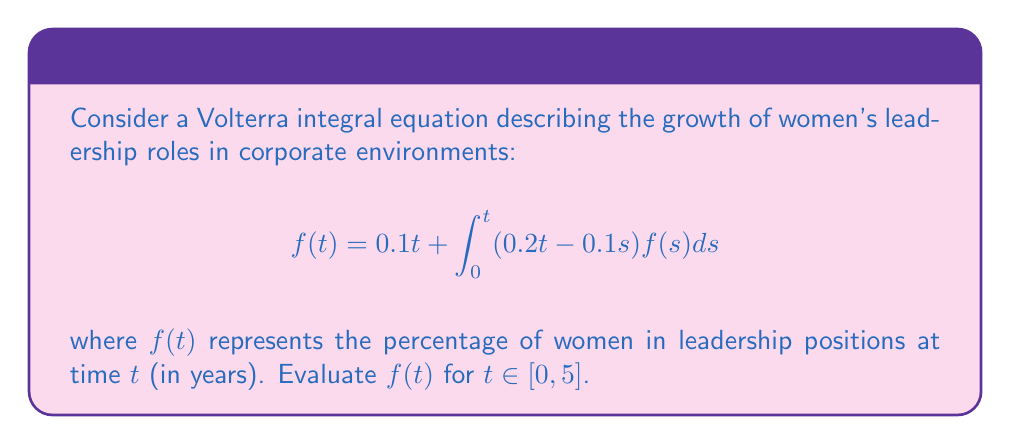Give your solution to this math problem. To solve this Volterra integral equation, we'll use the method of successive approximations:

1) Start with an initial approximation: $f_0(t) = 0.1t$

2) Use the iterative formula:
   $$f_{n+1}(t) = 0.1t + \int_0^t (0.2t - 0.1s)f_n(s)ds$$

3) First iteration:
   $$f_1(t) = 0.1t + \int_0^t (0.2t - 0.1s)(0.1s)ds$$
   $$= 0.1t + 0.2t\int_0^t 0.1sds - 0.1\int_0^t 0.1s^2ds$$
   $$= 0.1t + 0.2t(0.05t^2) - 0.1(0.033t^3)$$
   $$= 0.1t + 0.01t^3 - 0.0033t^3 = 0.1t + 0.0067t^3$$

4) Second iteration:
   $$f_2(t) = 0.1t + \int_0^t (0.2t - 0.1s)(0.1s + 0.0067s^3)ds$$
   $$= 0.1t + 0.2t\int_0^t (0.1s + 0.0067s^3)ds - 0.1\int_0^t (0.1s^2 + 0.0067s^4)ds$$
   $$= 0.1t + 0.2t(0.05t^2 + 0.00134t^4) - 0.1(0.033t^3 + 0.00134t^5)$$
   $$= 0.1t + 0.01t^3 + 0.000268t^5 - 0.0033t^3 - 0.000134t^5$$
   $$= 0.1t + 0.0067t^3 + 0.000134t^5$$

5) The solution converges quickly. We can approximate $f(t)$ as:
   $$f(t) \approx 0.1t + 0.0067t^3 + 0.000134t^5$$

6) Evaluating for $t \in [0, 5]$:
   $f(0) = 0$
   $f(1) \approx 0.1067$
   $f(2) \approx 0.2602$
   $f(3) \approx 0.5445$
   $f(4) \approx 1.0355$
   $f(5) \approx 1.8084$
Answer: $f(t) \approx 0.1t + 0.0067t^3 + 0.000134t^5$ 